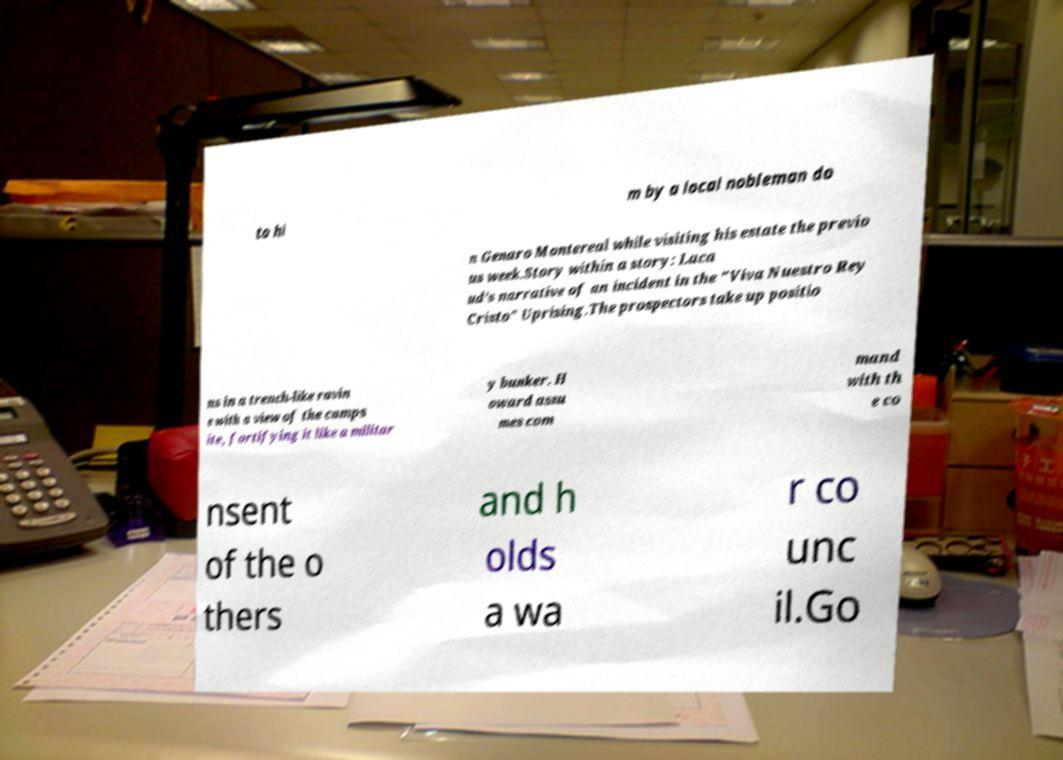Can you accurately transcribe the text from the provided image for me? to hi m by a local nobleman do n Genaro Montereal while visiting his estate the previo us week.Story within a story: Laca ud’s narrative of an incident in the "Viva Nuestro Rey Cristo" Uprising.The prospectors take up positio ns in a trench-like ravin e with a view of the camps ite, fortifying it like a militar y bunker. H oward assu mes com mand with th e co nsent of the o thers and h olds a wa r co unc il.Go 